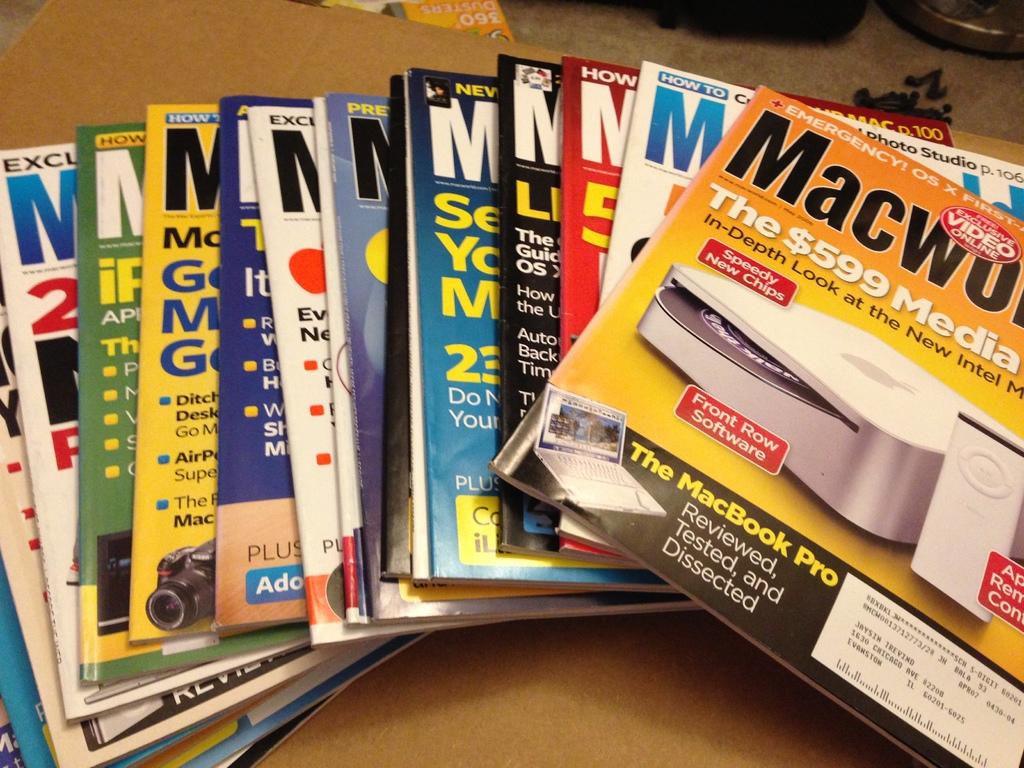Which magazine is that?
Provide a short and direct response. Macworld. 